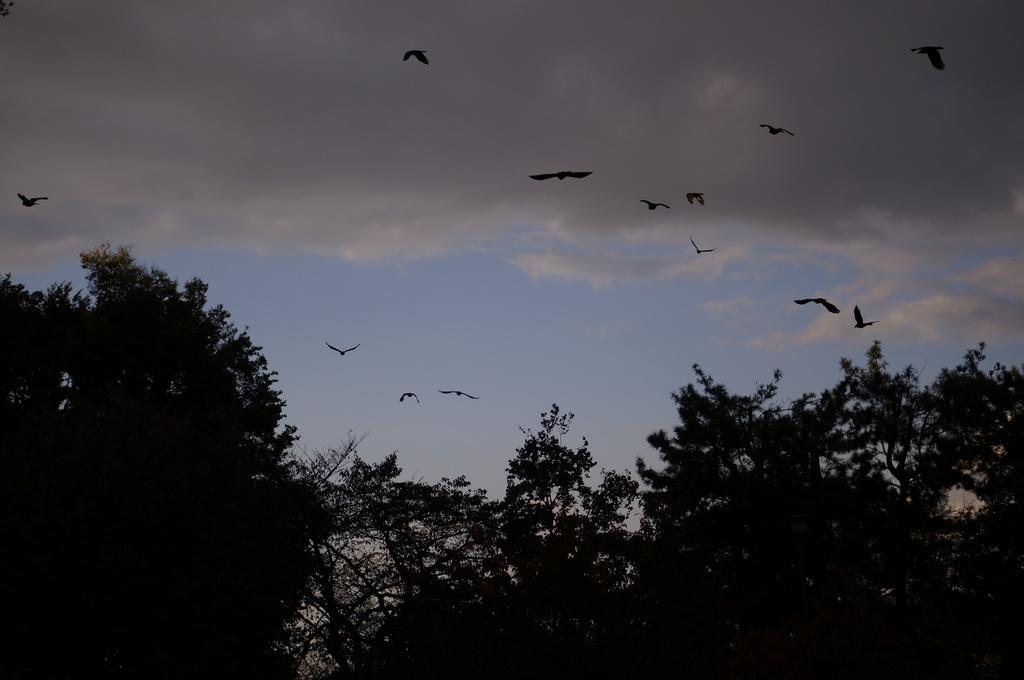What type of vegetation is at the bottom of the image? There are trees at the bottom of the image. What is happening in the center of the image? There are birds flying in the center of the image. What part of the natural environment is visible at the top of the image? The sky is visible at the top of the image. What is the ladybug's desire in the image? There is no ladybug present in the image, so it is not possible to determine its desires. How many bridges can be seen in the image? There are no bridges visible in the image. 